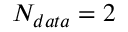Convert formula to latex. <formula><loc_0><loc_0><loc_500><loc_500>N _ { d a t a } = 2</formula> 